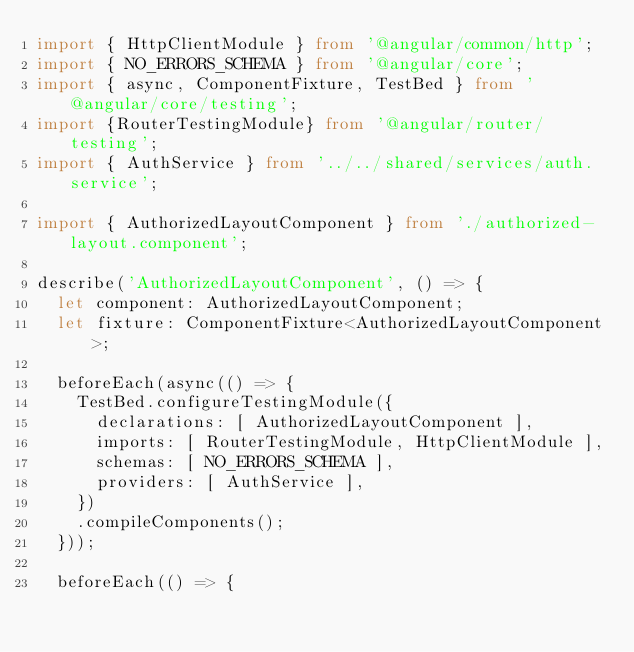<code> <loc_0><loc_0><loc_500><loc_500><_TypeScript_>import { HttpClientModule } from '@angular/common/http';
import { NO_ERRORS_SCHEMA } from '@angular/core';
import { async, ComponentFixture, TestBed } from '@angular/core/testing';
import {RouterTestingModule} from '@angular/router/testing';
import { AuthService } from '../../shared/services/auth.service';

import { AuthorizedLayoutComponent } from './authorized-layout.component';

describe('AuthorizedLayoutComponent', () => {
  let component: AuthorizedLayoutComponent;
  let fixture: ComponentFixture<AuthorizedLayoutComponent>;

  beforeEach(async(() => {
    TestBed.configureTestingModule({
      declarations: [ AuthorizedLayoutComponent ],
      imports: [ RouterTestingModule, HttpClientModule ],
      schemas: [ NO_ERRORS_SCHEMA ],
      providers: [ AuthService ],
    })
    .compileComponents();
  }));

  beforeEach(() => {</code> 